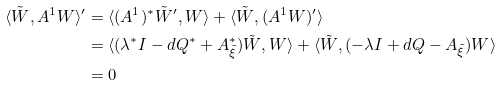Convert formula to latex. <formula><loc_0><loc_0><loc_500><loc_500>\langle \tilde { W } , A ^ { 1 } W \rangle ^ { \prime } & = \langle ( A ^ { 1 } ) ^ { * } \tilde { W } ^ { \prime } , W \rangle + \langle \tilde { W } , ( A ^ { 1 } W ) ^ { \prime } \rangle \\ & = \langle ( \lambda ^ { * } I - d Q ^ { * } + A _ { \tilde { \xi } } ^ { * } ) \tilde { W } , W \rangle + \langle \tilde { W } , ( - \lambda I + d Q - A _ { \tilde { \xi } } ) W \rangle \\ & = 0</formula> 